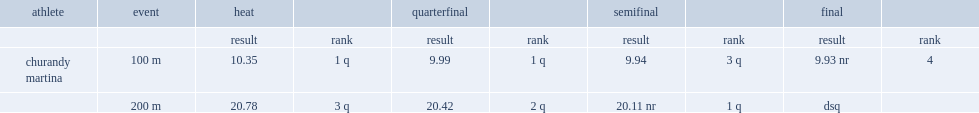What was the result that churandy martina got in the semifinals? 9.94. 